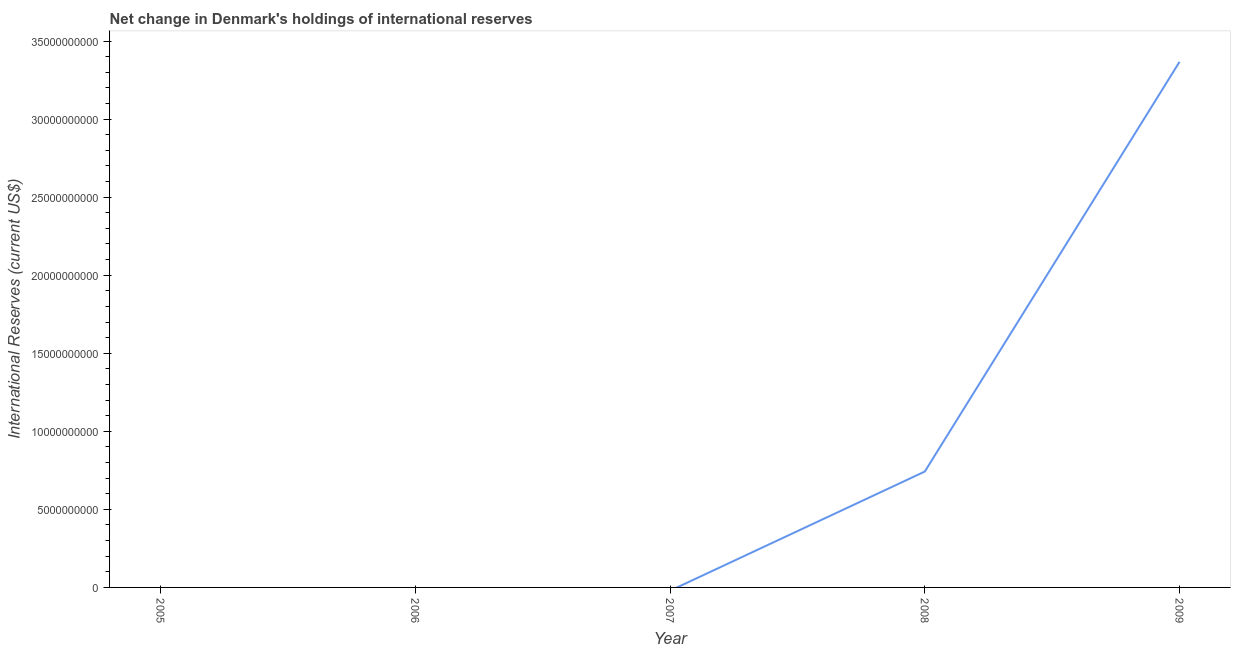What is the reserves and related items in 2005?
Provide a short and direct response. 0. Across all years, what is the maximum reserves and related items?
Provide a succinct answer. 3.37e+1. In which year was the reserves and related items maximum?
Your answer should be very brief. 2009. What is the sum of the reserves and related items?
Keep it short and to the point. 4.11e+1. What is the difference between the reserves and related items in 2008 and 2009?
Make the answer very short. -2.62e+1. What is the average reserves and related items per year?
Offer a very short reply. 8.22e+09. What is the median reserves and related items?
Make the answer very short. 0. Is the sum of the reserves and related items in 2008 and 2009 greater than the maximum reserves and related items across all years?
Give a very brief answer. Yes. What is the difference between the highest and the lowest reserves and related items?
Make the answer very short. 3.37e+1. Does the reserves and related items monotonically increase over the years?
Offer a terse response. No. What is the difference between two consecutive major ticks on the Y-axis?
Ensure brevity in your answer.  5.00e+09. Are the values on the major ticks of Y-axis written in scientific E-notation?
Offer a very short reply. No. Does the graph contain grids?
Offer a terse response. No. What is the title of the graph?
Ensure brevity in your answer.  Net change in Denmark's holdings of international reserves. What is the label or title of the Y-axis?
Your answer should be compact. International Reserves (current US$). What is the International Reserves (current US$) of 2006?
Offer a very short reply. 0. What is the International Reserves (current US$) of 2008?
Your answer should be very brief. 7.42e+09. What is the International Reserves (current US$) in 2009?
Provide a short and direct response. 3.37e+1. What is the difference between the International Reserves (current US$) in 2008 and 2009?
Offer a very short reply. -2.62e+1. What is the ratio of the International Reserves (current US$) in 2008 to that in 2009?
Your response must be concise. 0.22. 